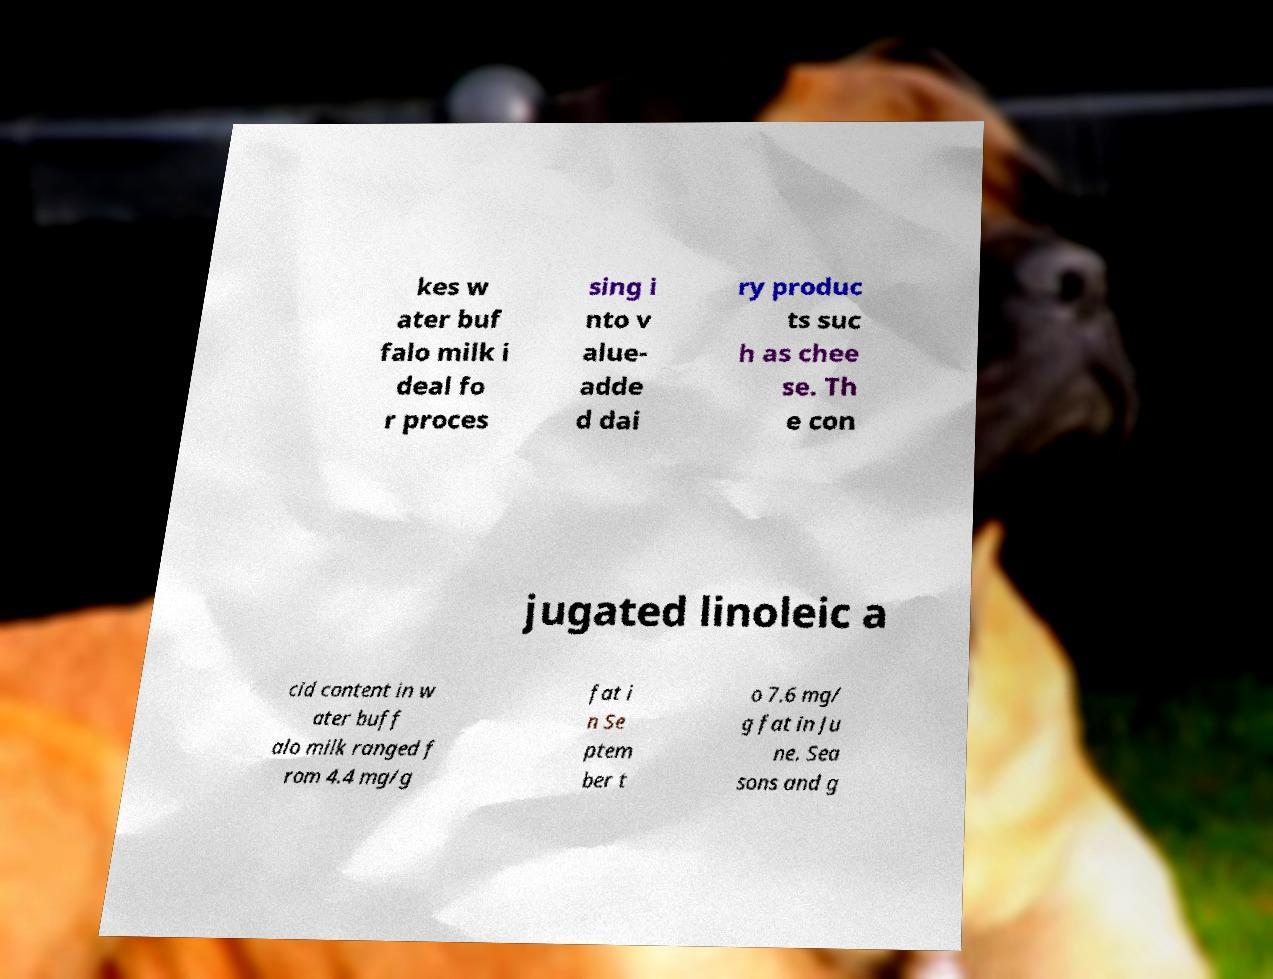Please read and relay the text visible in this image. What does it say? kes w ater buf falo milk i deal fo r proces sing i nto v alue- adde d dai ry produc ts suc h as chee se. Th e con jugated linoleic a cid content in w ater buff alo milk ranged f rom 4.4 mg/g fat i n Se ptem ber t o 7.6 mg/ g fat in Ju ne. Sea sons and g 